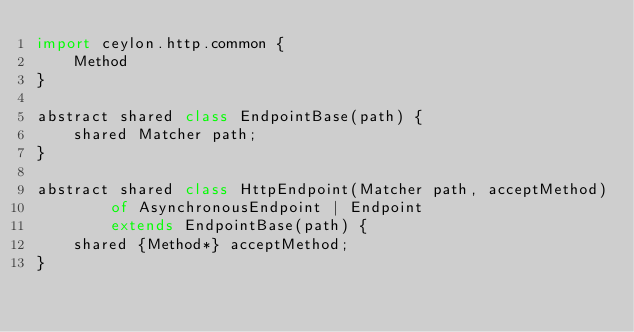Convert code to text. <code><loc_0><loc_0><loc_500><loc_500><_Ceylon_>import ceylon.http.common {
    Method
}

abstract shared class EndpointBase(path) {
    shared Matcher path;
}

abstract shared class HttpEndpoint(Matcher path, acceptMethod) 
        of AsynchronousEndpoint | Endpoint 
        extends EndpointBase(path) {
    shared {Method*} acceptMethod;
}
</code> 